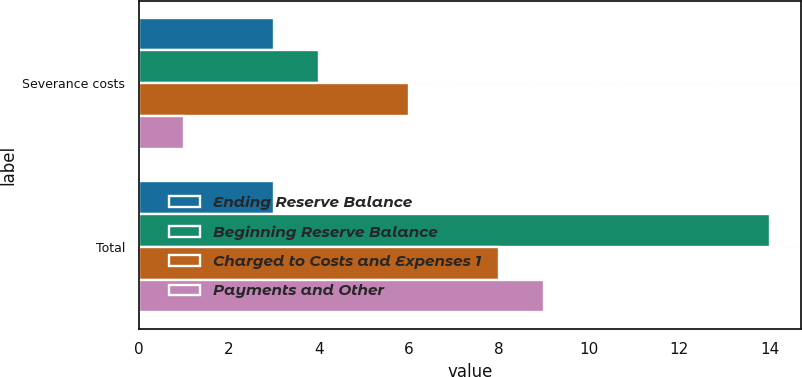Convert chart to OTSL. <chart><loc_0><loc_0><loc_500><loc_500><stacked_bar_chart><ecel><fcel>Severance costs<fcel>Total<nl><fcel>Ending Reserve Balance<fcel>3<fcel>3<nl><fcel>Beginning Reserve Balance<fcel>4<fcel>14<nl><fcel>Charged to Costs and Expenses 1<fcel>6<fcel>8<nl><fcel>Payments and Other<fcel>1<fcel>9<nl></chart> 